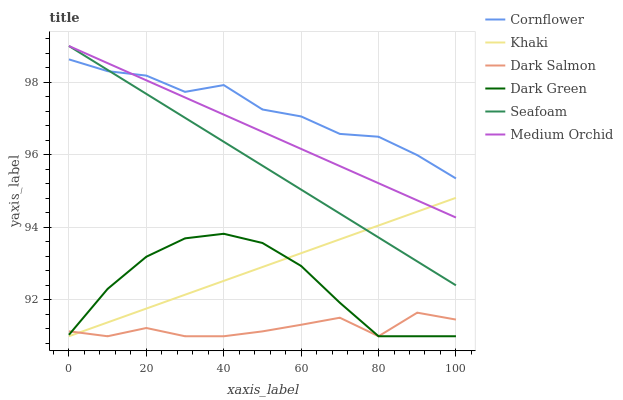Does Khaki have the minimum area under the curve?
Answer yes or no. No. Does Khaki have the maximum area under the curve?
Answer yes or no. No. Is Medium Orchid the smoothest?
Answer yes or no. No. Is Medium Orchid the roughest?
Answer yes or no. No. Does Medium Orchid have the lowest value?
Answer yes or no. No. Does Khaki have the highest value?
Answer yes or no. No. Is Dark Salmon less than Cornflower?
Answer yes or no. Yes. Is Medium Orchid greater than Dark Salmon?
Answer yes or no. Yes. Does Dark Salmon intersect Cornflower?
Answer yes or no. No. 